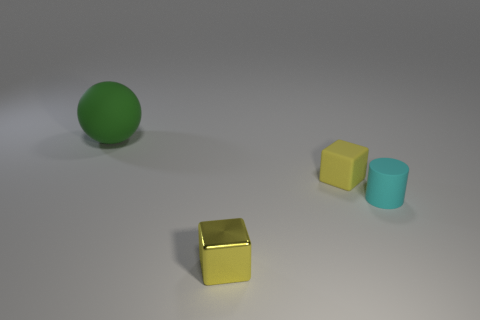Is there anything else that has the same size as the green matte sphere?
Give a very brief answer. No. Do the metallic block and the matte cube have the same color?
Keep it short and to the point. Yes. Are there any other things that have the same color as the small matte cylinder?
Provide a succinct answer. No. Is the color of the tiny metallic object the same as the tiny rubber object that is left of the cyan rubber thing?
Offer a very short reply. Yes. There is a tiny matte object in front of the tiny yellow object behind the shiny block; what shape is it?
Ensure brevity in your answer.  Cylinder. Does the small rubber object that is to the left of the cyan cylinder have the same shape as the cyan object?
Your response must be concise. No. Are there more small yellow metal things that are to the right of the large green matte sphere than small cylinders that are to the left of the cyan thing?
Keep it short and to the point. Yes. There is a tiny block that is in front of the small cylinder; how many tiny yellow blocks are on the right side of it?
Give a very brief answer. 1. There is another object that is the same color as the small metal object; what is it made of?
Give a very brief answer. Rubber. How many other things are there of the same color as the rubber ball?
Your answer should be very brief. 0. 